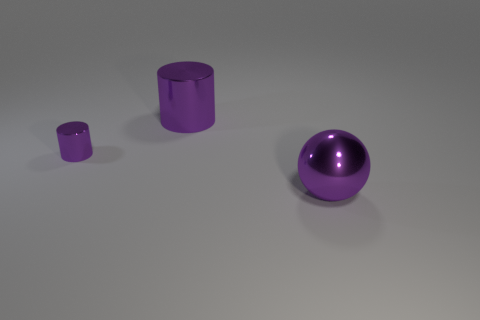Is there a tiny object behind the big purple shiny thing that is in front of the small purple thing?
Ensure brevity in your answer.  Yes. How many purple metal balls are behind the tiny shiny thing that is in front of the large purple shiny object that is on the left side of the purple sphere?
Give a very brief answer. 0. What color is the object that is both on the right side of the tiny purple metal cylinder and in front of the big cylinder?
Give a very brief answer. Purple. How many tiny objects are the same color as the ball?
Offer a terse response. 1. What number of blocks are either small purple metallic things or big purple shiny things?
Give a very brief answer. 0. There is a metal cylinder that is the same size as the shiny sphere; what color is it?
Your answer should be very brief. Purple. There is a big object right of the purple cylinder right of the tiny thing; are there any large purple metal objects behind it?
Your answer should be compact. Yes. What number of objects are either purple metal balls or cyan metallic objects?
Offer a very short reply. 1. The big cylinder that is made of the same material as the small thing is what color?
Your answer should be very brief. Purple. Is the shape of the purple thing that is behind the small purple shiny cylinder the same as  the small purple metal object?
Provide a succinct answer. Yes. 